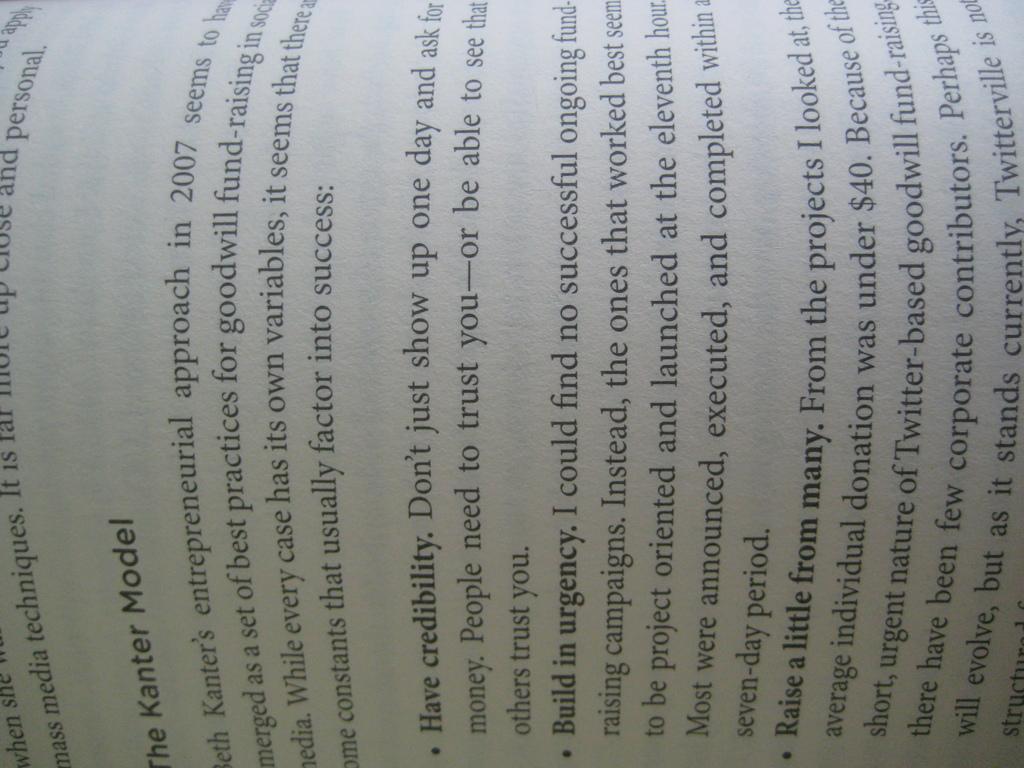What is this book about?
Your answer should be very brief. The kanter model. What is the first bold words?
Your answer should be very brief. The kanter model. 